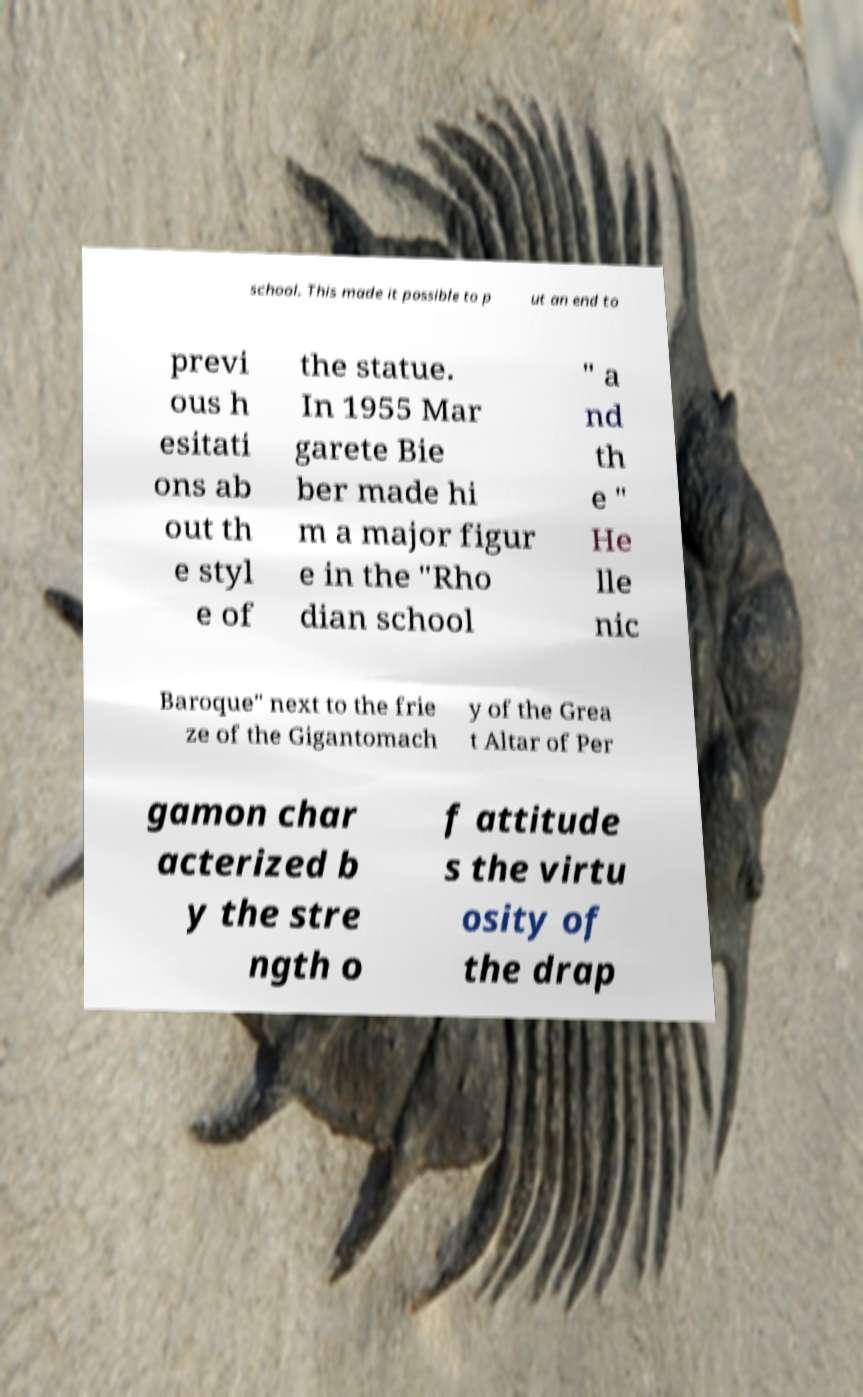For documentation purposes, I need the text within this image transcribed. Could you provide that? school. This made it possible to p ut an end to previ ous h esitati ons ab out th e styl e of the statue. In 1955 Mar garete Bie ber made hi m a major figur e in the "Rho dian school " a nd th e " He lle nic Baroque" next to the frie ze of the Gigantomach y of the Grea t Altar of Per gamon char acterized b y the stre ngth o f attitude s the virtu osity of the drap 